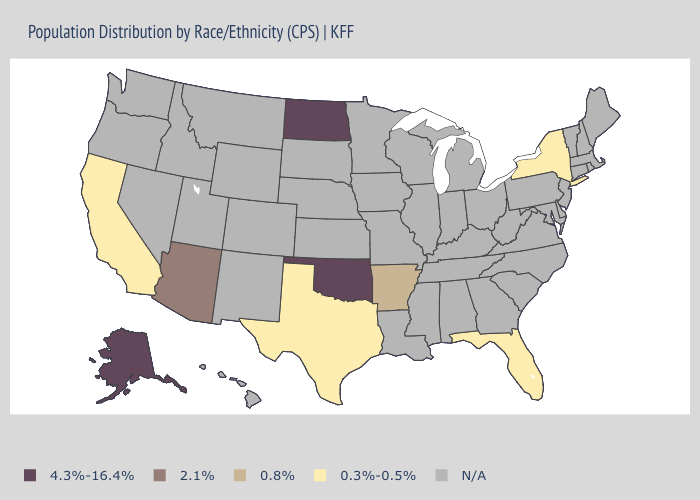Does Arkansas have the lowest value in the USA?
Write a very short answer. No. What is the highest value in the USA?
Keep it brief. 4.3%-16.4%. Which states hav the highest value in the West?
Give a very brief answer. Alaska. Name the states that have a value in the range 0.3%-0.5%?
Keep it brief. California, Florida, New York, Texas. What is the lowest value in the Northeast?
Keep it brief. 0.3%-0.5%. How many symbols are there in the legend?
Give a very brief answer. 5. Does the map have missing data?
Write a very short answer. Yes. Does the map have missing data?
Short answer required. Yes. Among the states that border Missouri , which have the lowest value?
Write a very short answer. Arkansas. What is the value of Nebraska?
Quick response, please. N/A. Among the states that border Arizona , which have the highest value?
Short answer required. California. How many symbols are there in the legend?
Quick response, please. 5. 